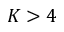Convert formula to latex. <formula><loc_0><loc_0><loc_500><loc_500>K > 4</formula> 